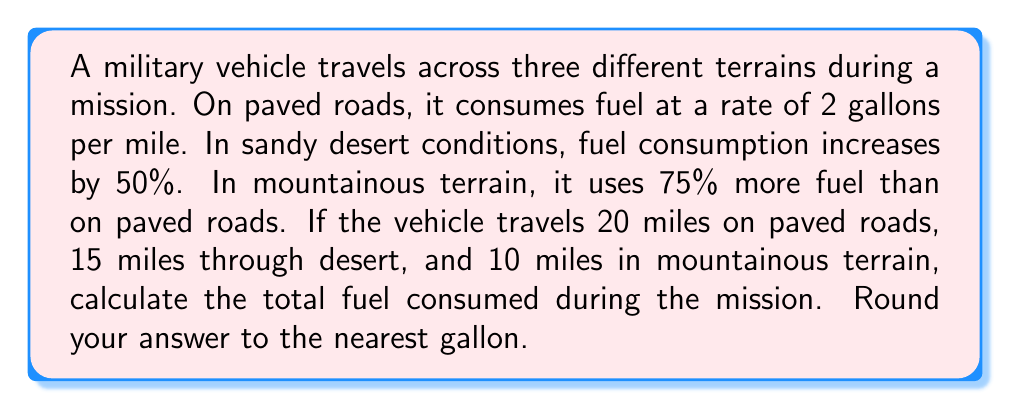Provide a solution to this math problem. Let's break this problem down step-by-step:

1. Fuel consumption on paved roads:
   - Rate: 2 gallons per mile
   - Distance: 20 miles
   - Fuel used: $20 \times 2 = 40$ gallons

2. Fuel consumption in desert:
   - Rate: 2 gallons per mile + 50% increase
   - New rate: $2 + (2 \times 0.50) = 3$ gallons per mile
   - Distance: 15 miles
   - Fuel used: $15 \times 3 = 45$ gallons

3. Fuel consumption in mountainous terrain:
   - Rate: 2 gallons per mile + 75% increase
   - New rate: $2 + (2 \times 0.75) = 3.5$ gallons per mile
   - Distance: 10 miles
   - Fuel used: $10 \times 3.5 = 35$ gallons

4. Total fuel consumed:
   $$ \text{Total Fuel} = 40 + 45 + 35 = 120 \text{ gallons} $$

Therefore, the total fuel consumed during the mission is 120 gallons.
Answer: 120 gallons 